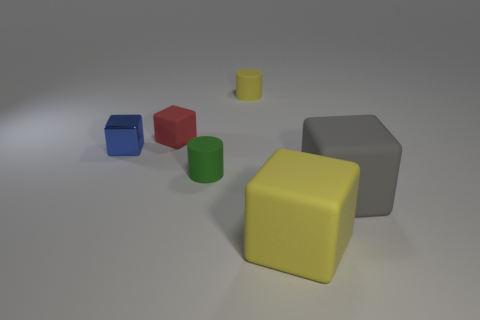Is there any other thing that is the same material as the blue thing?
Ensure brevity in your answer.  No. There is a yellow thing in front of the red rubber object; how big is it?
Give a very brief answer. Large. What number of red metal spheres have the same size as the green cylinder?
Your answer should be compact. 0. There is a red cube; is it the same size as the cube that is on the left side of the small red matte thing?
Your answer should be compact. Yes. What number of things are either yellow cubes or gray rubber objects?
Make the answer very short. 2. How many other cubes have the same color as the tiny shiny block?
Keep it short and to the point. 0. What is the shape of the yellow rubber thing that is the same size as the blue shiny block?
Give a very brief answer. Cylinder. Is there another rubber object that has the same shape as the large yellow matte object?
Ensure brevity in your answer.  Yes. What number of other small red cubes have the same material as the red cube?
Offer a very short reply. 0. Is the small cylinder in front of the tiny rubber cube made of the same material as the big gray object?
Ensure brevity in your answer.  Yes. 